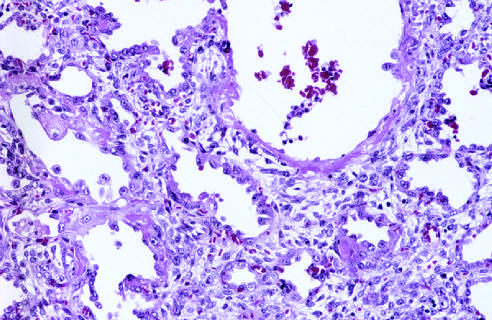s the healing stage marked by resorption of hyaline membranes and thickening of alveolar septa by inflammatory cells, fibroblasts, and collagen?
Answer the question using a single word or phrase. Yes 